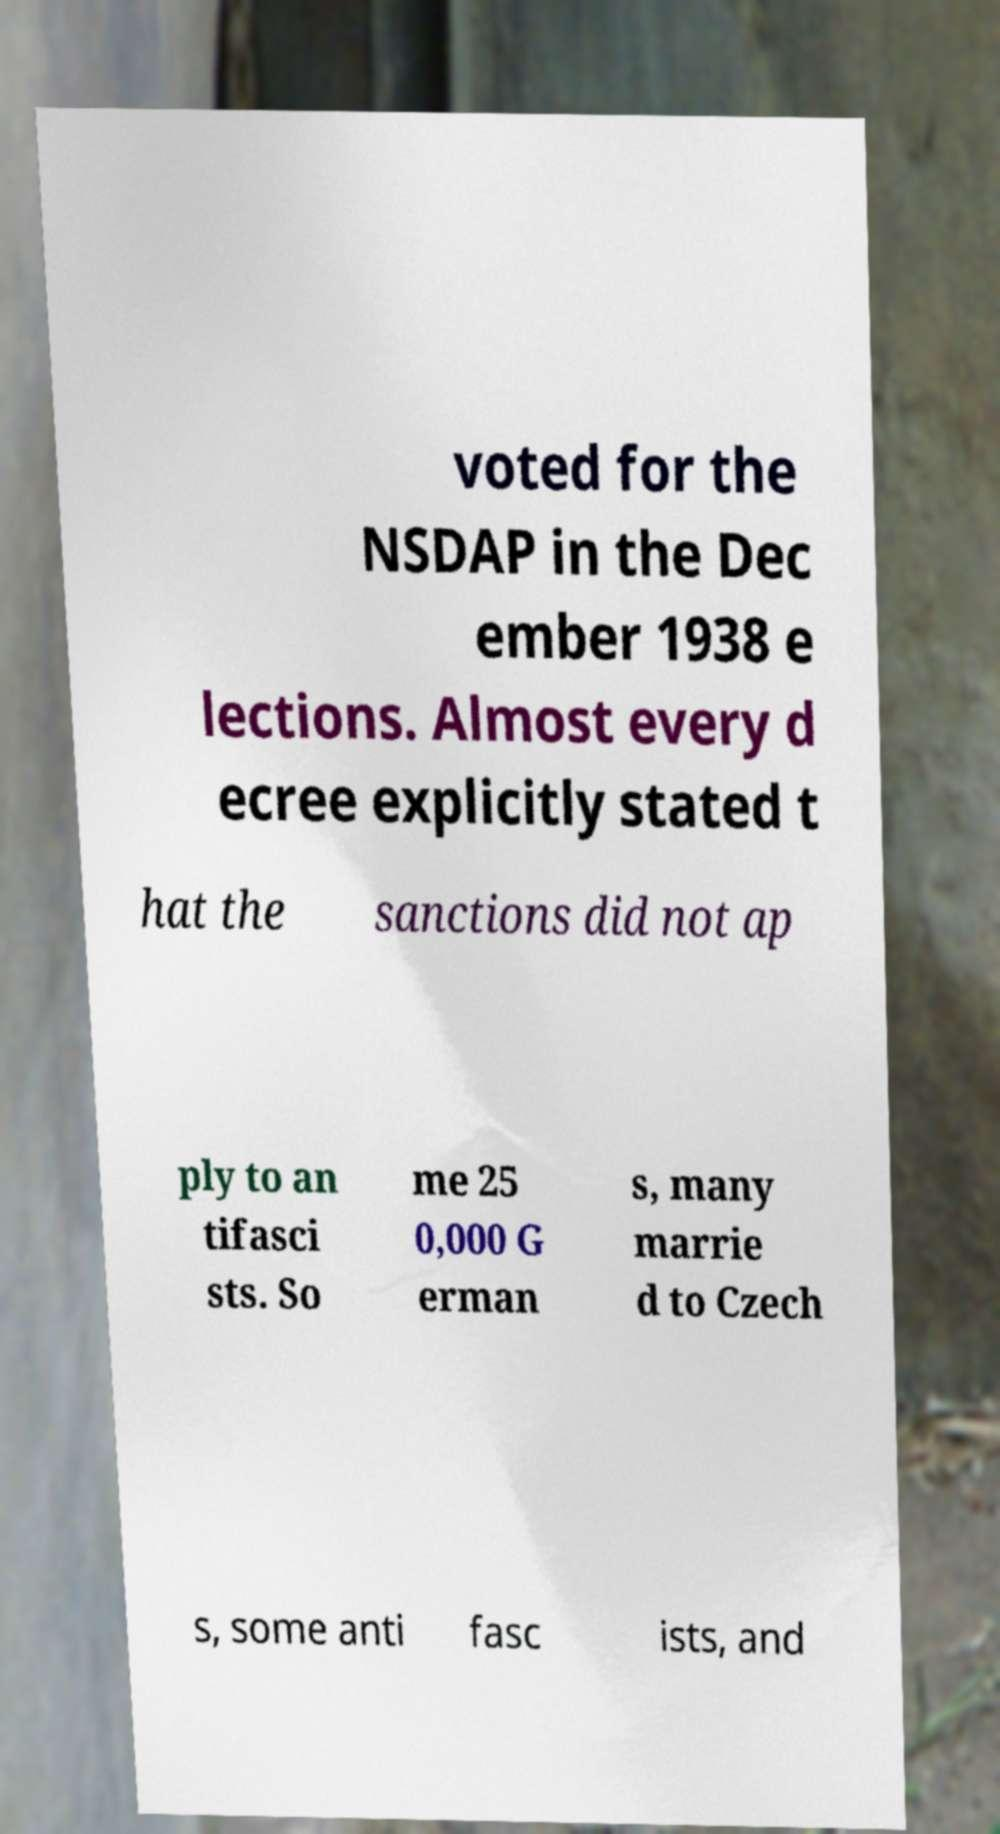Please identify and transcribe the text found in this image. voted for the NSDAP in the Dec ember 1938 e lections. Almost every d ecree explicitly stated t hat the sanctions did not ap ply to an tifasci sts. So me 25 0,000 G erman s, many marrie d to Czech s, some anti fasc ists, and 